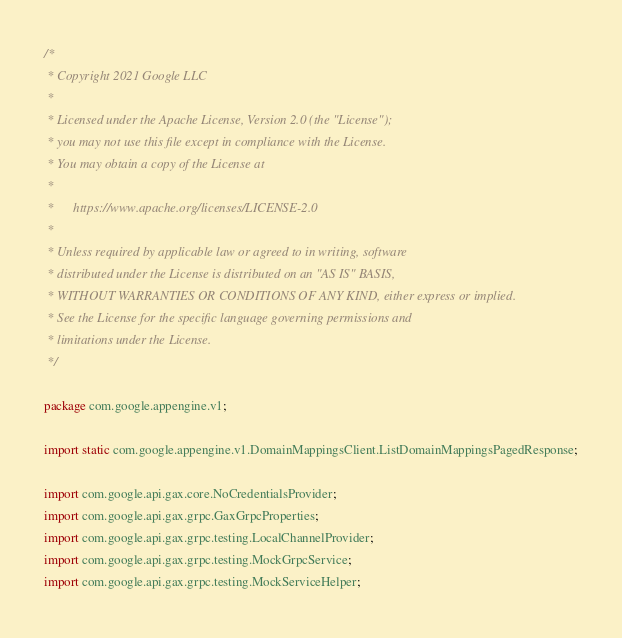<code> <loc_0><loc_0><loc_500><loc_500><_Java_>/*
 * Copyright 2021 Google LLC
 *
 * Licensed under the Apache License, Version 2.0 (the "License");
 * you may not use this file except in compliance with the License.
 * You may obtain a copy of the License at
 *
 *      https://www.apache.org/licenses/LICENSE-2.0
 *
 * Unless required by applicable law or agreed to in writing, software
 * distributed under the License is distributed on an "AS IS" BASIS,
 * WITHOUT WARRANTIES OR CONDITIONS OF ANY KIND, either express or implied.
 * See the License for the specific language governing permissions and
 * limitations under the License.
 */

package com.google.appengine.v1;

import static com.google.appengine.v1.DomainMappingsClient.ListDomainMappingsPagedResponse;

import com.google.api.gax.core.NoCredentialsProvider;
import com.google.api.gax.grpc.GaxGrpcProperties;
import com.google.api.gax.grpc.testing.LocalChannelProvider;
import com.google.api.gax.grpc.testing.MockGrpcService;
import com.google.api.gax.grpc.testing.MockServiceHelper;</code> 